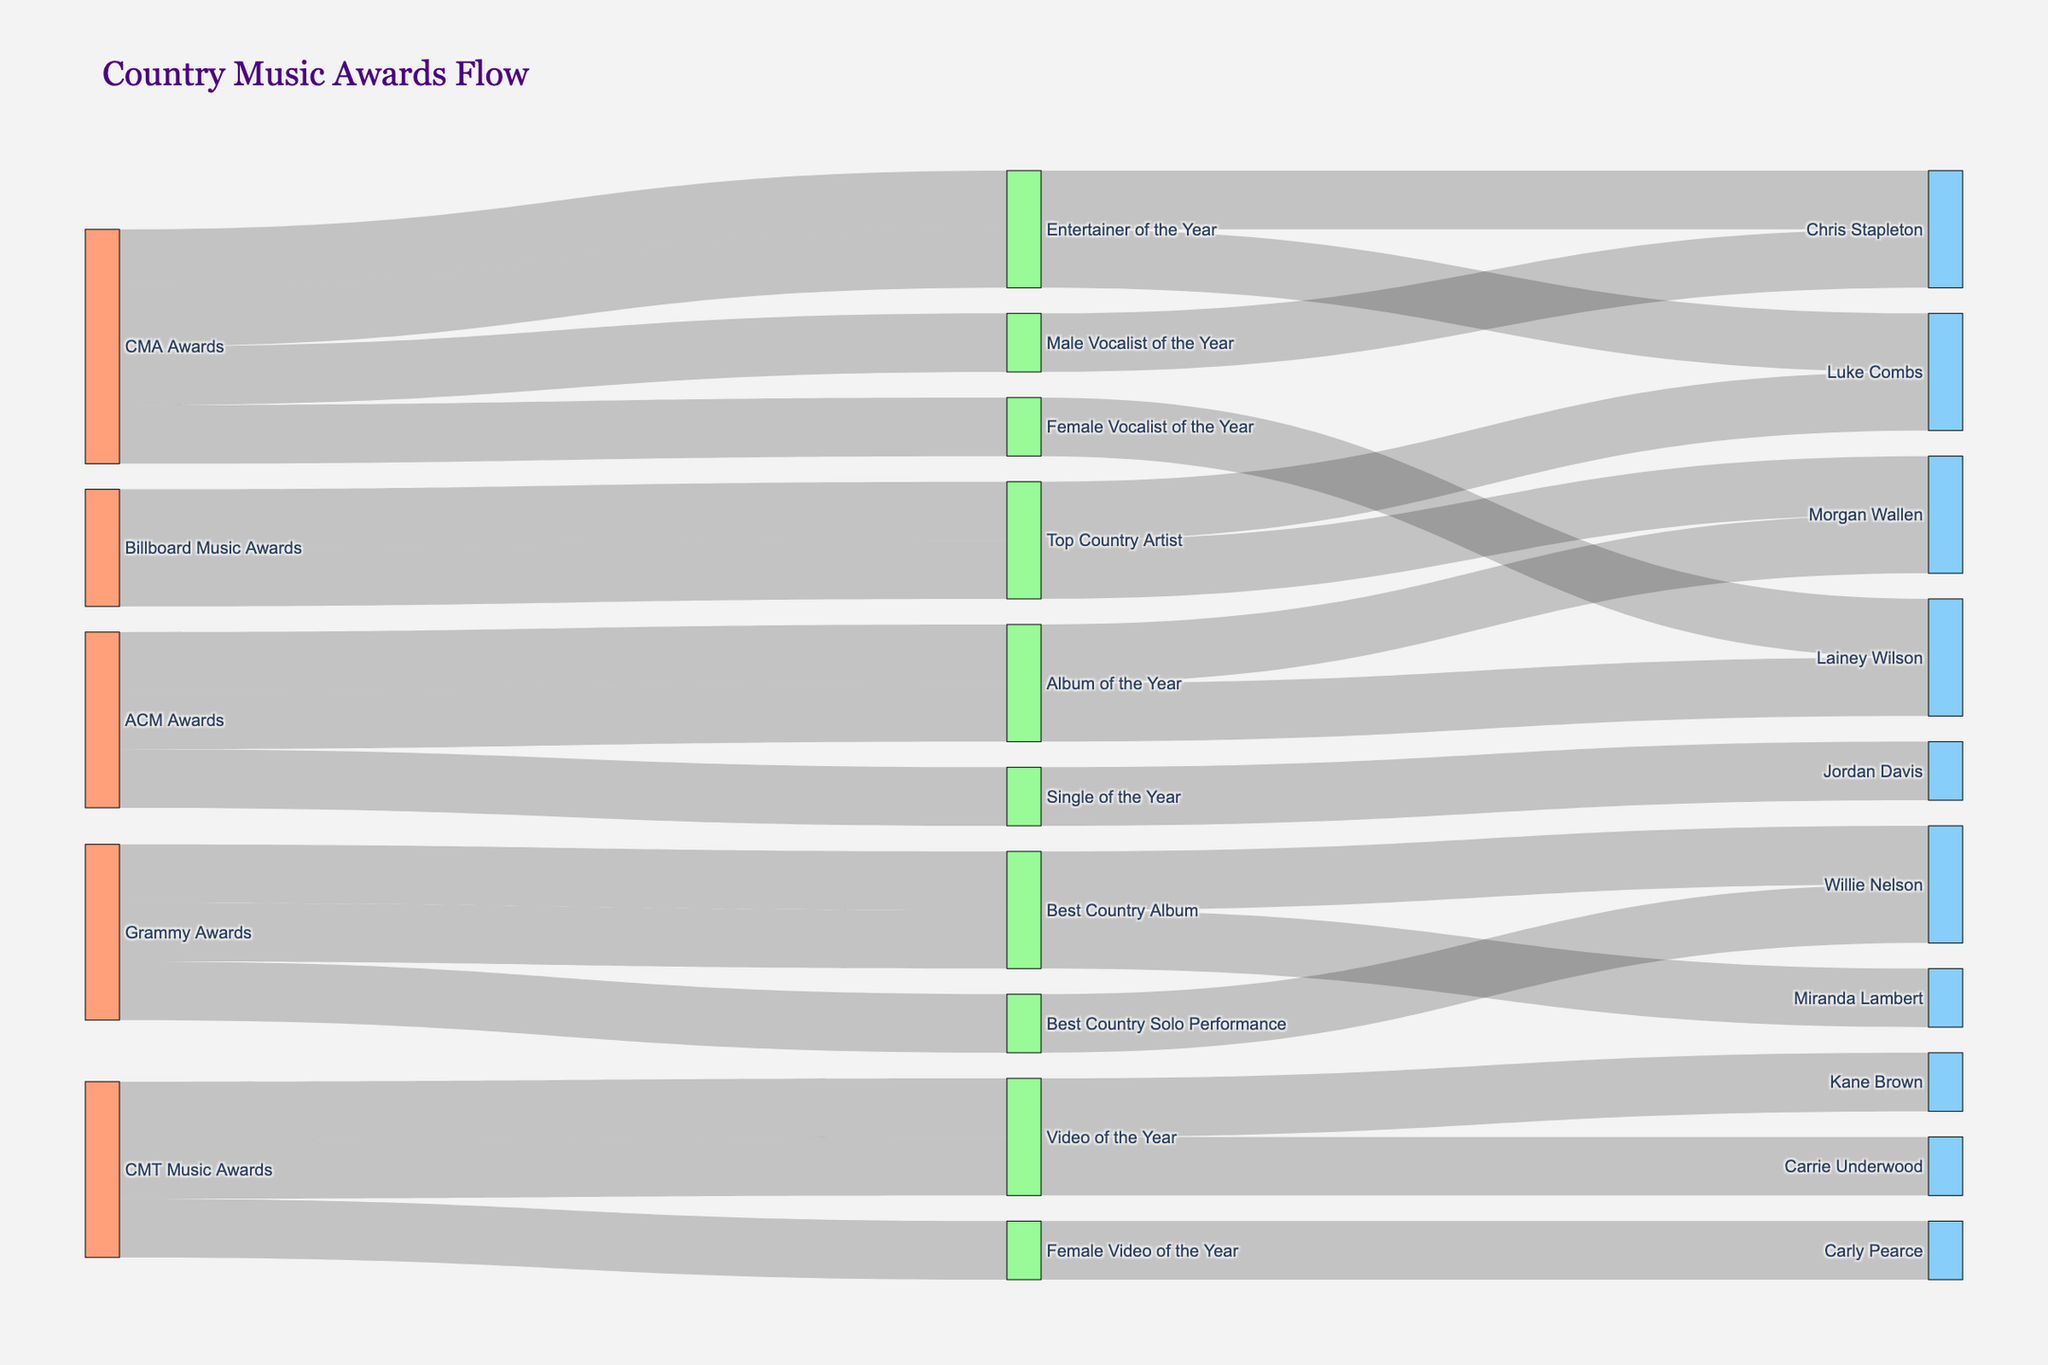What's the title of the diagram? The title of the diagram is displayed at the top of the figure. It reads "Country Music Awards Flow".
Answer: Country Music Awards Flow Which award show has the category "Best Country Solo Performance"? The category "Best Country Solo Performance" is linked to "Grammy Awards" in the Sankey diagram.
Answer: Grammy Awards How many nominees were there in total across all award shows? Count the nodes classified as nominees in the Sankey diagram. Each nominee node is a unique label past the category nodes. There are 11 nominees in total.
Answer: 11 Who won the "Top Country Artist" award at the Billboard Music Awards? Follow the flow from the "Billboard Music Awards" node to the "Top Country Artist" category and see the connected nominee nodes. The winner is Morgan Wallen.
Answer: Morgan Wallen How many awards did Lainey Wilson win across all award shows? Trace all the flows that end at the nominee node "Lainey Wilson". There are two flows indicating that she won two awards: "Female Vocalist of the Year" in CMA Awards and "Album of the Year" in ACM Awards.
Answer: 2 Compare the number of wins for Luke Combs and Chris Stapleton. Who has more wins? Trace the flows ending at the nominee nodes for Luke Combs and Chris Stapleton. Luke Combs has 1 win (Entertainer of the Year in CMA Awards) whereas Chris Stapleton also has 1 win (Male Vocalist of the Year in CMA Awards). They have equal wins.
Answer: Equal Which award show had the highest number of categories represented in the diagram? Count the distinct category nodes originating from each award show. CMA Awards has 3 categories, ACM Awards has 2 categories, Grammy Awards has 2 categories, CMT Music Awards has 2 categories, and Billboard Music Awards has 1 category. CMA Awards has the highest number of categories.
Answer: CMA Awards How many categories are there in total across all awards? Count the distinct category nodes in the diagram. There are 7 unique categories in total.
Answer: 7 Is there any nominee that appears in more than one award show? Follow the flows from all award shows to the nominee nodes. No nominee node is connected to more than one award show.
Answer: No Who won the "Video of the Year" award at the CMT Music Awards? Follow the flow from the "CMT Music Awards" node to the "Video of the Year" category and see the connected nominee nodes. The winner is Kane Brown.
Answer: Kane Brown 